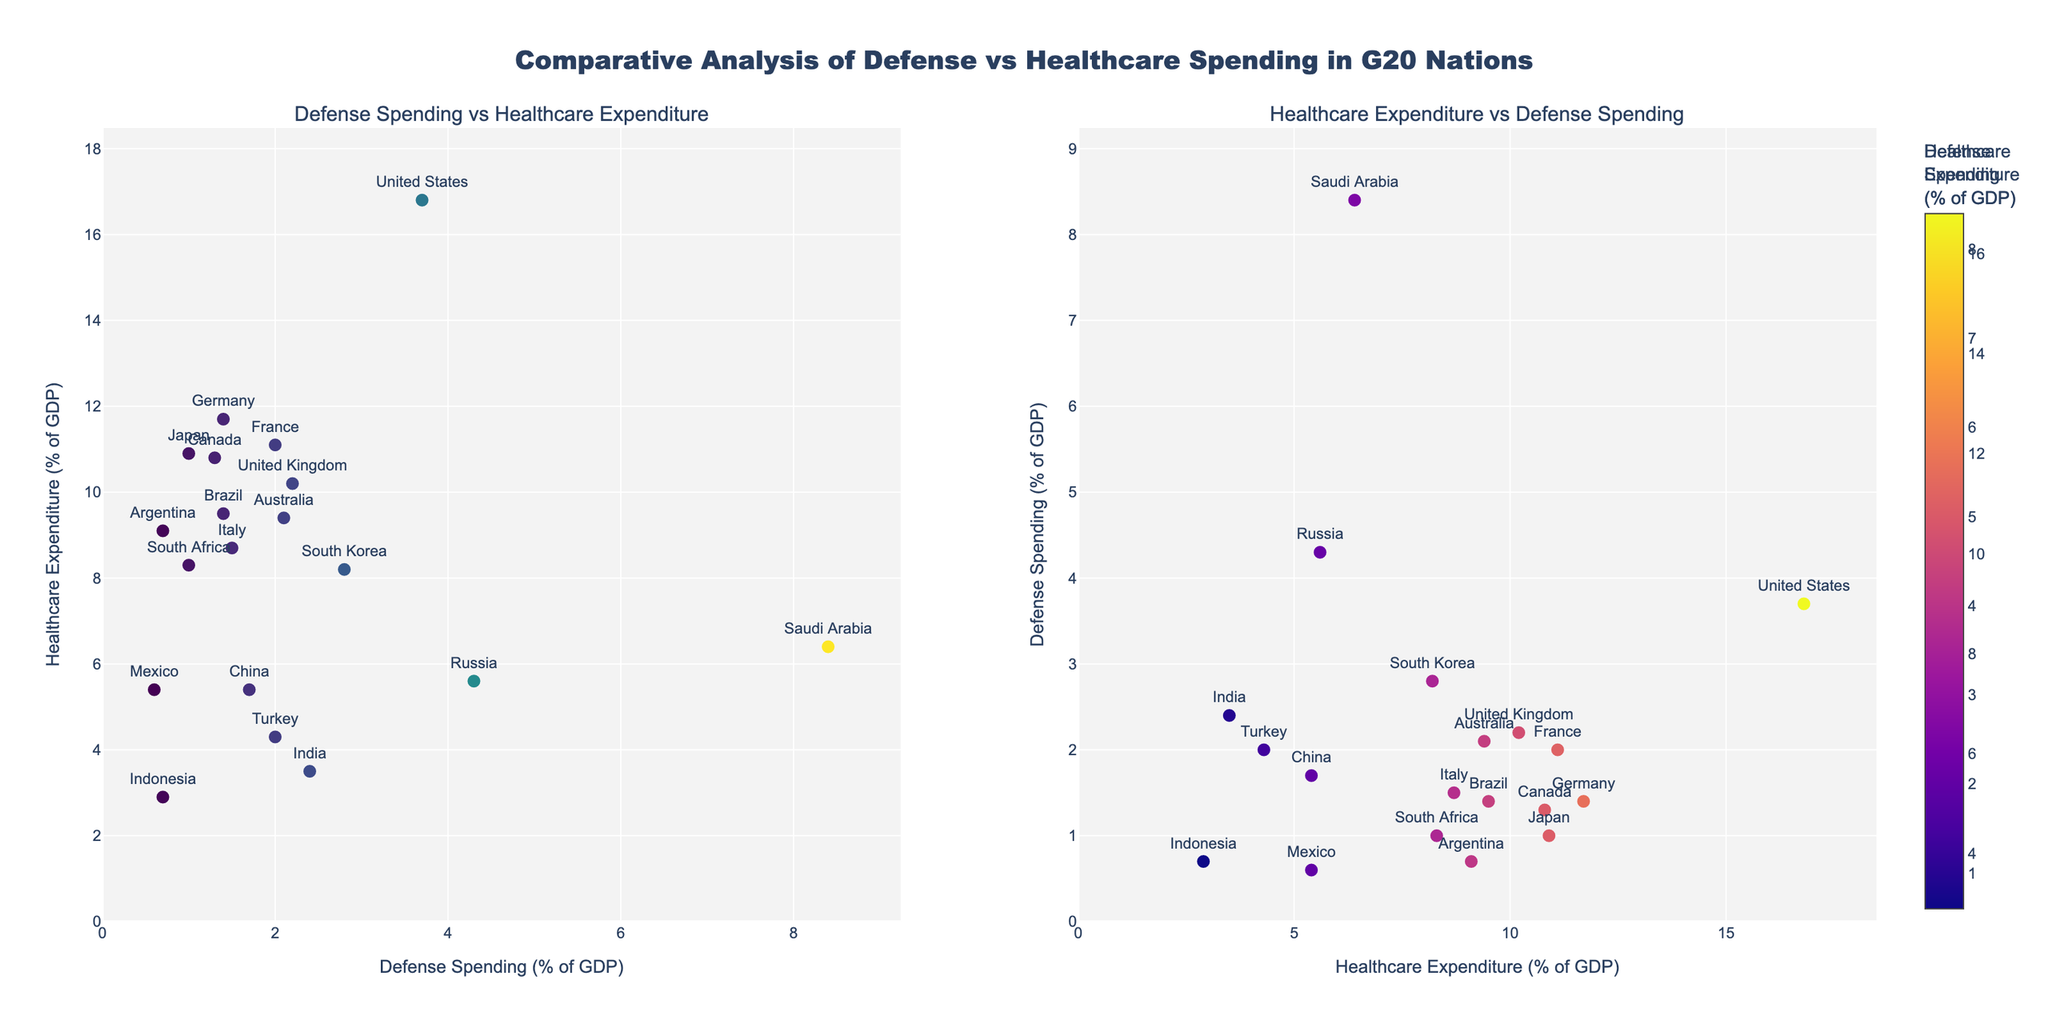What are the titles of the subplots? The titles are "Defense Spending vs Healthcare Expenditure" and "Healthcare Expenditure vs Defense Spending." These titles are displayed at the top of each subplot.
Answer: "Defense Spending vs Healthcare Expenditure" and "Healthcare Expenditure vs Defense Spending" Which country spends the highest percentage of its GDP on defense? By examining the x-axis values of the left subplot and looking for the largest value, you can see that Saudi Arabia has the highest defense spending at 8.4% of GDP.
Answer: Saudi Arabia How many G20 countries spend more than 10% of their GDP on healthcare? From the y-axis values of the left subplot and the x-axis values of the right subplot, count the countries above 10% on healthcare. These countries are the United States, Japan, Germany, the United Kingdom, France, and Canada.
Answer: 6 Which country has the lowest healthcare expenditure, and what is its value? Locate the smallest value on the y-axis of the left subplot. Indonesia has the lowest healthcare expenditure, which is 2.9% of GDP.
Answer: Indonesia, 2.9% Is there any G20 country that spends more than 8% on both defense and healthcare? Examine both subplots for any marker positioned above 8% on both x and y axes. No data point meets this criteria.
Answer: No Which country has the highest healthcare expenditure, and what is its value? Locate the highest value on the y-axis of the left subplot. The United States has the highest healthcare expenditure, which is 16.8% of GDP.
Answer: United States, 16.8% Compare the defense spending of Russia and South Korea. Look for the position of Russia and South Korea on the x-axis of the left subplot. Russia spends 4.3% of its GDP on defense, while South Korea spends 2.8%.
Answer: Russia spends more (4.3%) than South Korea (2.8%) Which countries have both defense and healthcare expenditures below 5% of GDP? Identify points in both subplots where values are below 5% on both axes. Mexico and Indonesia fit this criterion.
Answer: Mexico and Indonesia What is the range of defense spending among G20 countries? Find the smallest and largest values on the x-axes of the left subplot. The smallest value is 0.6% (Mexico), and the largest is 8.4% (Saudi Arabia). Therefore, the range is 8.4% - 0.6% = 7.8%.
Answer: 7.8% What is the average healthcare expenditure of the G20 countries? Add all the healthcare expenditure values and divide by the number of countries (19). The total is 1.7(China) + 10.9(Japan) + 11.7(Germany) + 3.5(India) + 10.2(UK) + 11.1(France) + 8.7(Italy) + 9.5(Brazil) + 10.8(Canada) + 5.6(Russia) + 8.2(South Korea) + 9.4(Australia) + 5.4(Mexico) + 2.9(Indonesia) + 4.3(Turkey) + 6.4(Saudi Arabia) + 9.1(Argentina) + 8.3(South Africa) + 16.8(US) = 165.7. Divide by 19, the average is 165.7 / 19 = 8.73%.
Answer: 8.73% 